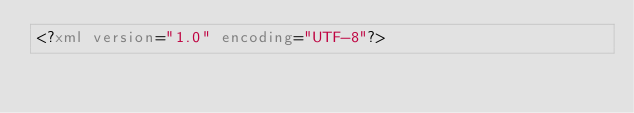Convert code to text. <code><loc_0><loc_0><loc_500><loc_500><_XML_><?xml version="1.0" encoding="UTF-8"?></code> 